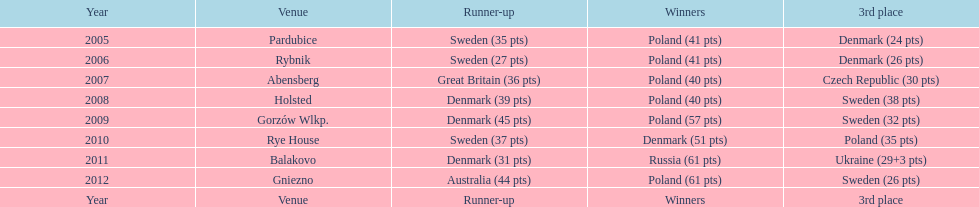What is the total number of points earned in the years 2009? 134. Parse the table in full. {'header': ['Year', 'Venue', 'Runner-up', 'Winners', '3rd place'], 'rows': [['2005', 'Pardubice', 'Sweden (35 pts)', 'Poland (41 pts)', 'Denmark (24 pts)'], ['2006', 'Rybnik', 'Sweden (27 pts)', 'Poland (41 pts)', 'Denmark (26 pts)'], ['2007', 'Abensberg', 'Great Britain (36 pts)', 'Poland (40 pts)', 'Czech Republic (30 pts)'], ['2008', 'Holsted', 'Denmark (39 pts)', 'Poland (40 pts)', 'Sweden (38 pts)'], ['2009', 'Gorzów Wlkp.', 'Denmark (45 pts)', 'Poland (57 pts)', 'Sweden (32 pts)'], ['2010', 'Rye House', 'Sweden (37 pts)', 'Denmark (51 pts)', 'Poland (35 pts)'], ['2011', 'Balakovo', 'Denmark (31 pts)', 'Russia (61 pts)', 'Ukraine (29+3 pts)'], ['2012', 'Gniezno', 'Australia (44 pts)', 'Poland (61 pts)', 'Sweden (26 pts)'], ['Year', 'Venue', 'Runner-up', 'Winners', '3rd place']]} 